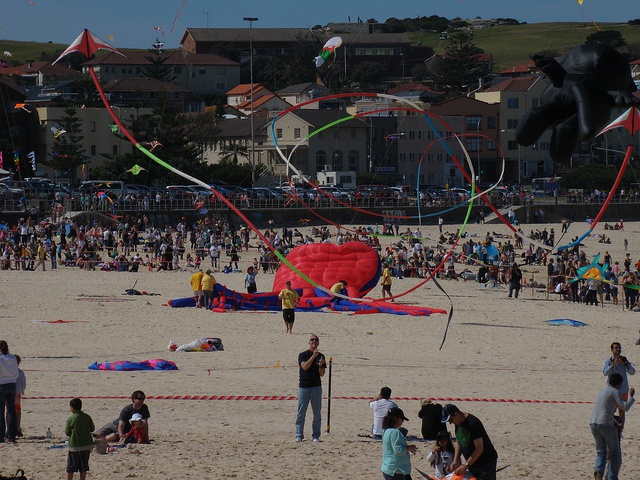Describe the objects in this image and their specific colors. I can see kite in gray, black, and darkblue tones, kite in gray, brown, maroon, and black tones, people in gray and black tones, people in gray and black tones, and people in gray, black, and navy tones in this image. 